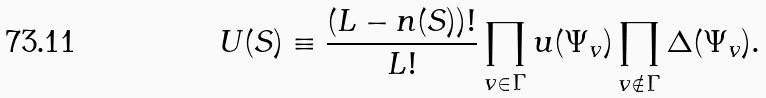Convert formula to latex. <formula><loc_0><loc_0><loc_500><loc_500>U ( S ) \equiv \frac { ( L - n ( S ) ) ! } { L ! } \prod _ { v \in \Gamma } u ( \Psi _ { v } ) \prod _ { v \notin \Gamma } \Delta ( \Psi _ { v } ) .</formula> 